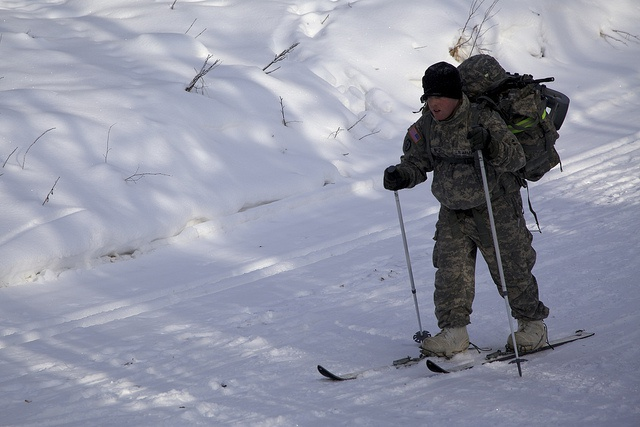Describe the objects in this image and their specific colors. I can see people in lightgray, black, and gray tones, backpack in lightgray, black, gray, and darkgreen tones, and skis in lightgray, black, and gray tones in this image. 